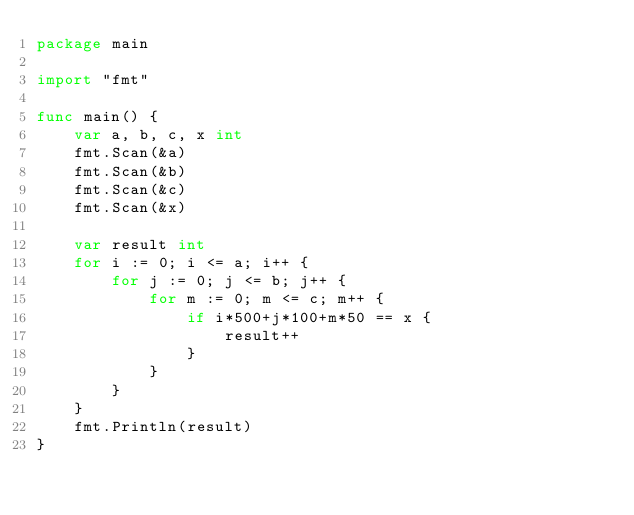<code> <loc_0><loc_0><loc_500><loc_500><_Go_>package main

import "fmt"

func main() {
	var a, b, c, x int
	fmt.Scan(&a)
	fmt.Scan(&b)
	fmt.Scan(&c)
	fmt.Scan(&x)

	var result int
	for i := 0; i <= a; i++ {
		for j := 0; j <= b; j++ {
			for m := 0; m <= c; m++ {
				if i*500+j*100+m*50 == x {
					result++
				}
			}
		}
	}
	fmt.Println(result)
}
</code> 